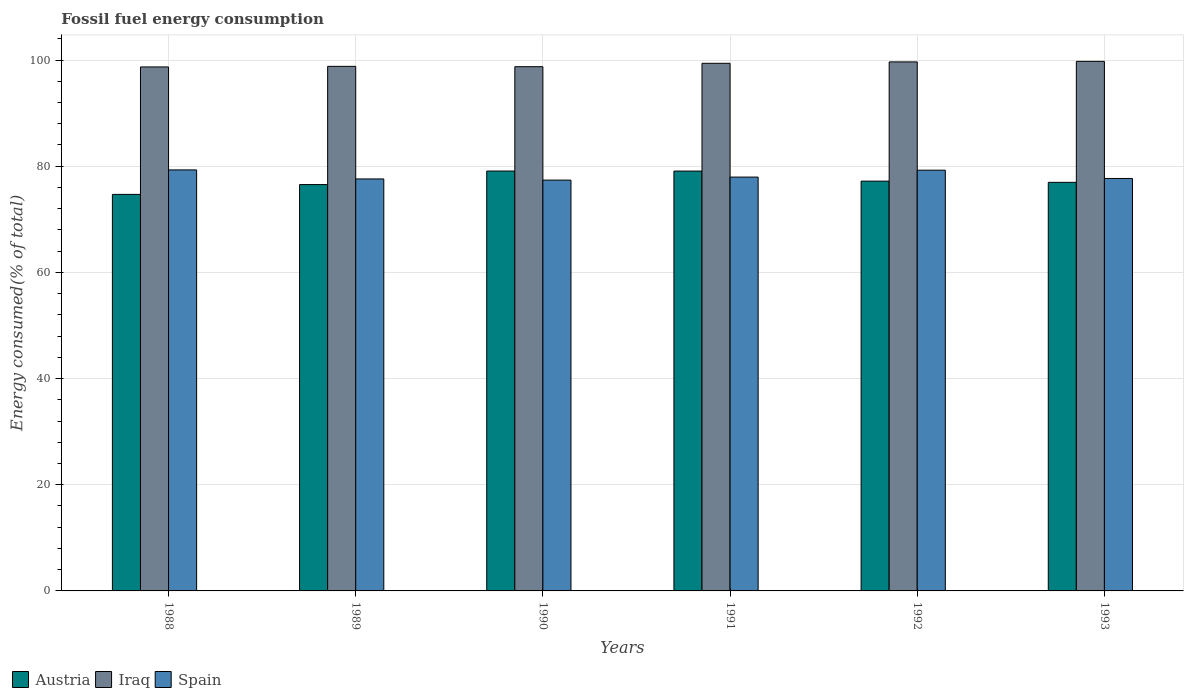How many groups of bars are there?
Offer a very short reply. 6. Are the number of bars per tick equal to the number of legend labels?
Offer a terse response. Yes. In how many cases, is the number of bars for a given year not equal to the number of legend labels?
Offer a very short reply. 0. What is the percentage of energy consumed in Austria in 1991?
Provide a succinct answer. 79.09. Across all years, what is the maximum percentage of energy consumed in Spain?
Offer a terse response. 79.3. Across all years, what is the minimum percentage of energy consumed in Austria?
Your response must be concise. 74.69. In which year was the percentage of energy consumed in Spain minimum?
Your response must be concise. 1990. What is the total percentage of energy consumed in Spain in the graph?
Make the answer very short. 469.19. What is the difference between the percentage of energy consumed in Spain in 1990 and that in 1993?
Your answer should be very brief. -0.31. What is the difference between the percentage of energy consumed in Spain in 1988 and the percentage of energy consumed in Iraq in 1993?
Make the answer very short. -20.45. What is the average percentage of energy consumed in Iraq per year?
Give a very brief answer. 99.18. In the year 1988, what is the difference between the percentage of energy consumed in Iraq and percentage of energy consumed in Spain?
Your answer should be compact. 19.4. In how many years, is the percentage of energy consumed in Spain greater than 56 %?
Offer a very short reply. 6. What is the ratio of the percentage of energy consumed in Spain in 1990 to that in 1991?
Your response must be concise. 0.99. Is the percentage of energy consumed in Spain in 1988 less than that in 1989?
Offer a very short reply. No. Is the difference between the percentage of energy consumed in Iraq in 1991 and 1993 greater than the difference between the percentage of energy consumed in Spain in 1991 and 1993?
Your answer should be compact. No. What is the difference between the highest and the second highest percentage of energy consumed in Austria?
Keep it short and to the point. 0.01. What is the difference between the highest and the lowest percentage of energy consumed in Spain?
Your answer should be very brief. 1.92. In how many years, is the percentage of energy consumed in Spain greater than the average percentage of energy consumed in Spain taken over all years?
Ensure brevity in your answer.  2. Is the sum of the percentage of energy consumed in Spain in 1990 and 1991 greater than the maximum percentage of energy consumed in Iraq across all years?
Provide a short and direct response. Yes. What does the 2nd bar from the left in 1993 represents?
Your answer should be compact. Iraq. What does the 3rd bar from the right in 1990 represents?
Your response must be concise. Austria. Is it the case that in every year, the sum of the percentage of energy consumed in Austria and percentage of energy consumed in Iraq is greater than the percentage of energy consumed in Spain?
Provide a succinct answer. Yes. Are all the bars in the graph horizontal?
Your answer should be very brief. No. How many years are there in the graph?
Make the answer very short. 6. Are the values on the major ticks of Y-axis written in scientific E-notation?
Provide a succinct answer. No. Does the graph contain any zero values?
Keep it short and to the point. No. Does the graph contain grids?
Offer a terse response. Yes. Where does the legend appear in the graph?
Offer a terse response. Bottom left. How many legend labels are there?
Keep it short and to the point. 3. What is the title of the graph?
Keep it short and to the point. Fossil fuel energy consumption. Does "Suriname" appear as one of the legend labels in the graph?
Your answer should be very brief. No. What is the label or title of the X-axis?
Your answer should be very brief. Years. What is the label or title of the Y-axis?
Provide a short and direct response. Energy consumed(% of total). What is the Energy consumed(% of total) of Austria in 1988?
Your answer should be very brief. 74.69. What is the Energy consumed(% of total) of Iraq in 1988?
Provide a short and direct response. 98.7. What is the Energy consumed(% of total) in Spain in 1988?
Make the answer very short. 79.3. What is the Energy consumed(% of total) in Austria in 1989?
Provide a short and direct response. 76.54. What is the Energy consumed(% of total) in Iraq in 1989?
Give a very brief answer. 98.81. What is the Energy consumed(% of total) of Spain in 1989?
Keep it short and to the point. 77.6. What is the Energy consumed(% of total) in Austria in 1990?
Ensure brevity in your answer.  79.09. What is the Energy consumed(% of total) of Iraq in 1990?
Provide a short and direct response. 98.75. What is the Energy consumed(% of total) of Spain in 1990?
Ensure brevity in your answer.  77.39. What is the Energy consumed(% of total) of Austria in 1991?
Your response must be concise. 79.09. What is the Energy consumed(% of total) in Iraq in 1991?
Keep it short and to the point. 99.39. What is the Energy consumed(% of total) of Spain in 1991?
Your response must be concise. 77.95. What is the Energy consumed(% of total) of Austria in 1992?
Your answer should be very brief. 77.19. What is the Energy consumed(% of total) in Iraq in 1992?
Give a very brief answer. 99.65. What is the Energy consumed(% of total) of Spain in 1992?
Give a very brief answer. 79.25. What is the Energy consumed(% of total) in Austria in 1993?
Your response must be concise. 76.96. What is the Energy consumed(% of total) in Iraq in 1993?
Your answer should be compact. 99.75. What is the Energy consumed(% of total) of Spain in 1993?
Provide a short and direct response. 77.69. Across all years, what is the maximum Energy consumed(% of total) in Austria?
Your answer should be very brief. 79.09. Across all years, what is the maximum Energy consumed(% of total) in Iraq?
Provide a succinct answer. 99.75. Across all years, what is the maximum Energy consumed(% of total) of Spain?
Provide a succinct answer. 79.3. Across all years, what is the minimum Energy consumed(% of total) in Austria?
Provide a short and direct response. 74.69. Across all years, what is the minimum Energy consumed(% of total) in Iraq?
Ensure brevity in your answer.  98.7. Across all years, what is the minimum Energy consumed(% of total) in Spain?
Give a very brief answer. 77.39. What is the total Energy consumed(% of total) in Austria in the graph?
Offer a terse response. 463.57. What is the total Energy consumed(% of total) in Iraq in the graph?
Your answer should be compact. 595.06. What is the total Energy consumed(% of total) in Spain in the graph?
Your answer should be very brief. 469.19. What is the difference between the Energy consumed(% of total) of Austria in 1988 and that in 1989?
Offer a terse response. -1.85. What is the difference between the Energy consumed(% of total) of Iraq in 1988 and that in 1989?
Your response must be concise. -0.11. What is the difference between the Energy consumed(% of total) of Spain in 1988 and that in 1989?
Provide a short and direct response. 1.7. What is the difference between the Energy consumed(% of total) of Austria in 1988 and that in 1990?
Ensure brevity in your answer.  -4.4. What is the difference between the Energy consumed(% of total) of Iraq in 1988 and that in 1990?
Ensure brevity in your answer.  -0.05. What is the difference between the Energy consumed(% of total) of Spain in 1988 and that in 1990?
Provide a succinct answer. 1.92. What is the difference between the Energy consumed(% of total) in Austria in 1988 and that in 1991?
Your answer should be compact. -4.39. What is the difference between the Energy consumed(% of total) of Iraq in 1988 and that in 1991?
Provide a succinct answer. -0.68. What is the difference between the Energy consumed(% of total) of Spain in 1988 and that in 1991?
Your response must be concise. 1.35. What is the difference between the Energy consumed(% of total) in Austria in 1988 and that in 1992?
Offer a very short reply. -2.5. What is the difference between the Energy consumed(% of total) in Iraq in 1988 and that in 1992?
Offer a terse response. -0.95. What is the difference between the Energy consumed(% of total) in Spain in 1988 and that in 1992?
Keep it short and to the point. 0.05. What is the difference between the Energy consumed(% of total) of Austria in 1988 and that in 1993?
Ensure brevity in your answer.  -2.27. What is the difference between the Energy consumed(% of total) in Iraq in 1988 and that in 1993?
Your response must be concise. -1.05. What is the difference between the Energy consumed(% of total) of Spain in 1988 and that in 1993?
Make the answer very short. 1.61. What is the difference between the Energy consumed(% of total) in Austria in 1989 and that in 1990?
Your answer should be compact. -2.55. What is the difference between the Energy consumed(% of total) of Iraq in 1989 and that in 1990?
Provide a short and direct response. 0.06. What is the difference between the Energy consumed(% of total) of Spain in 1989 and that in 1990?
Your response must be concise. 0.22. What is the difference between the Energy consumed(% of total) of Austria in 1989 and that in 1991?
Provide a succinct answer. -2.54. What is the difference between the Energy consumed(% of total) in Iraq in 1989 and that in 1991?
Your answer should be very brief. -0.57. What is the difference between the Energy consumed(% of total) in Spain in 1989 and that in 1991?
Offer a very short reply. -0.35. What is the difference between the Energy consumed(% of total) of Austria in 1989 and that in 1992?
Your answer should be compact. -0.65. What is the difference between the Energy consumed(% of total) of Iraq in 1989 and that in 1992?
Give a very brief answer. -0.84. What is the difference between the Energy consumed(% of total) in Spain in 1989 and that in 1992?
Provide a short and direct response. -1.65. What is the difference between the Energy consumed(% of total) of Austria in 1989 and that in 1993?
Your response must be concise. -0.42. What is the difference between the Energy consumed(% of total) in Iraq in 1989 and that in 1993?
Keep it short and to the point. -0.94. What is the difference between the Energy consumed(% of total) in Spain in 1989 and that in 1993?
Make the answer very short. -0.09. What is the difference between the Energy consumed(% of total) of Austria in 1990 and that in 1991?
Make the answer very short. 0.01. What is the difference between the Energy consumed(% of total) in Iraq in 1990 and that in 1991?
Give a very brief answer. -0.64. What is the difference between the Energy consumed(% of total) in Spain in 1990 and that in 1991?
Keep it short and to the point. -0.57. What is the difference between the Energy consumed(% of total) of Austria in 1990 and that in 1992?
Provide a short and direct response. 1.9. What is the difference between the Energy consumed(% of total) in Iraq in 1990 and that in 1992?
Your answer should be compact. -0.9. What is the difference between the Energy consumed(% of total) of Spain in 1990 and that in 1992?
Keep it short and to the point. -1.87. What is the difference between the Energy consumed(% of total) in Austria in 1990 and that in 1993?
Give a very brief answer. 2.13. What is the difference between the Energy consumed(% of total) in Iraq in 1990 and that in 1993?
Provide a succinct answer. -1. What is the difference between the Energy consumed(% of total) in Spain in 1990 and that in 1993?
Provide a short and direct response. -0.31. What is the difference between the Energy consumed(% of total) of Austria in 1991 and that in 1992?
Your response must be concise. 1.89. What is the difference between the Energy consumed(% of total) in Iraq in 1991 and that in 1992?
Your answer should be compact. -0.26. What is the difference between the Energy consumed(% of total) of Spain in 1991 and that in 1992?
Your answer should be compact. -1.3. What is the difference between the Energy consumed(% of total) of Austria in 1991 and that in 1993?
Keep it short and to the point. 2.12. What is the difference between the Energy consumed(% of total) in Iraq in 1991 and that in 1993?
Ensure brevity in your answer.  -0.37. What is the difference between the Energy consumed(% of total) in Spain in 1991 and that in 1993?
Make the answer very short. 0.26. What is the difference between the Energy consumed(% of total) in Austria in 1992 and that in 1993?
Make the answer very short. 0.23. What is the difference between the Energy consumed(% of total) in Iraq in 1992 and that in 1993?
Make the answer very short. -0.1. What is the difference between the Energy consumed(% of total) in Spain in 1992 and that in 1993?
Keep it short and to the point. 1.56. What is the difference between the Energy consumed(% of total) of Austria in 1988 and the Energy consumed(% of total) of Iraq in 1989?
Your response must be concise. -24.12. What is the difference between the Energy consumed(% of total) of Austria in 1988 and the Energy consumed(% of total) of Spain in 1989?
Provide a succinct answer. -2.91. What is the difference between the Energy consumed(% of total) in Iraq in 1988 and the Energy consumed(% of total) in Spain in 1989?
Your answer should be compact. 21.1. What is the difference between the Energy consumed(% of total) in Austria in 1988 and the Energy consumed(% of total) in Iraq in 1990?
Your answer should be very brief. -24.06. What is the difference between the Energy consumed(% of total) of Austria in 1988 and the Energy consumed(% of total) of Spain in 1990?
Offer a very short reply. -2.69. What is the difference between the Energy consumed(% of total) in Iraq in 1988 and the Energy consumed(% of total) in Spain in 1990?
Give a very brief answer. 21.32. What is the difference between the Energy consumed(% of total) in Austria in 1988 and the Energy consumed(% of total) in Iraq in 1991?
Offer a terse response. -24.69. What is the difference between the Energy consumed(% of total) of Austria in 1988 and the Energy consumed(% of total) of Spain in 1991?
Keep it short and to the point. -3.26. What is the difference between the Energy consumed(% of total) of Iraq in 1988 and the Energy consumed(% of total) of Spain in 1991?
Your answer should be compact. 20.75. What is the difference between the Energy consumed(% of total) of Austria in 1988 and the Energy consumed(% of total) of Iraq in 1992?
Your response must be concise. -24.96. What is the difference between the Energy consumed(% of total) in Austria in 1988 and the Energy consumed(% of total) in Spain in 1992?
Make the answer very short. -4.56. What is the difference between the Energy consumed(% of total) of Iraq in 1988 and the Energy consumed(% of total) of Spain in 1992?
Provide a succinct answer. 19.45. What is the difference between the Energy consumed(% of total) in Austria in 1988 and the Energy consumed(% of total) in Iraq in 1993?
Keep it short and to the point. -25.06. What is the difference between the Energy consumed(% of total) in Austria in 1988 and the Energy consumed(% of total) in Spain in 1993?
Provide a succinct answer. -3. What is the difference between the Energy consumed(% of total) of Iraq in 1988 and the Energy consumed(% of total) of Spain in 1993?
Make the answer very short. 21.01. What is the difference between the Energy consumed(% of total) of Austria in 1989 and the Energy consumed(% of total) of Iraq in 1990?
Offer a very short reply. -22.2. What is the difference between the Energy consumed(% of total) in Austria in 1989 and the Energy consumed(% of total) in Spain in 1990?
Provide a short and direct response. -0.84. What is the difference between the Energy consumed(% of total) of Iraq in 1989 and the Energy consumed(% of total) of Spain in 1990?
Make the answer very short. 21.43. What is the difference between the Energy consumed(% of total) in Austria in 1989 and the Energy consumed(% of total) in Iraq in 1991?
Keep it short and to the point. -22.84. What is the difference between the Energy consumed(% of total) of Austria in 1989 and the Energy consumed(% of total) of Spain in 1991?
Give a very brief answer. -1.41. What is the difference between the Energy consumed(% of total) in Iraq in 1989 and the Energy consumed(% of total) in Spain in 1991?
Your answer should be very brief. 20.86. What is the difference between the Energy consumed(% of total) in Austria in 1989 and the Energy consumed(% of total) in Iraq in 1992?
Keep it short and to the point. -23.11. What is the difference between the Energy consumed(% of total) in Austria in 1989 and the Energy consumed(% of total) in Spain in 1992?
Ensure brevity in your answer.  -2.71. What is the difference between the Energy consumed(% of total) of Iraq in 1989 and the Energy consumed(% of total) of Spain in 1992?
Your response must be concise. 19.56. What is the difference between the Energy consumed(% of total) in Austria in 1989 and the Energy consumed(% of total) in Iraq in 1993?
Keep it short and to the point. -23.21. What is the difference between the Energy consumed(% of total) of Austria in 1989 and the Energy consumed(% of total) of Spain in 1993?
Keep it short and to the point. -1.15. What is the difference between the Energy consumed(% of total) in Iraq in 1989 and the Energy consumed(% of total) in Spain in 1993?
Offer a terse response. 21.12. What is the difference between the Energy consumed(% of total) of Austria in 1990 and the Energy consumed(% of total) of Iraq in 1991?
Keep it short and to the point. -20.3. What is the difference between the Energy consumed(% of total) in Austria in 1990 and the Energy consumed(% of total) in Spain in 1991?
Offer a very short reply. 1.14. What is the difference between the Energy consumed(% of total) in Iraq in 1990 and the Energy consumed(% of total) in Spain in 1991?
Offer a terse response. 20.8. What is the difference between the Energy consumed(% of total) of Austria in 1990 and the Energy consumed(% of total) of Iraq in 1992?
Make the answer very short. -20.56. What is the difference between the Energy consumed(% of total) in Austria in 1990 and the Energy consumed(% of total) in Spain in 1992?
Your answer should be very brief. -0.16. What is the difference between the Energy consumed(% of total) in Iraq in 1990 and the Energy consumed(% of total) in Spain in 1992?
Give a very brief answer. 19.49. What is the difference between the Energy consumed(% of total) of Austria in 1990 and the Energy consumed(% of total) of Iraq in 1993?
Offer a very short reply. -20.66. What is the difference between the Energy consumed(% of total) in Austria in 1990 and the Energy consumed(% of total) in Spain in 1993?
Offer a terse response. 1.4. What is the difference between the Energy consumed(% of total) in Iraq in 1990 and the Energy consumed(% of total) in Spain in 1993?
Provide a succinct answer. 21.06. What is the difference between the Energy consumed(% of total) of Austria in 1991 and the Energy consumed(% of total) of Iraq in 1992?
Your response must be concise. -20.56. What is the difference between the Energy consumed(% of total) of Austria in 1991 and the Energy consumed(% of total) of Spain in 1992?
Your answer should be compact. -0.17. What is the difference between the Energy consumed(% of total) of Iraq in 1991 and the Energy consumed(% of total) of Spain in 1992?
Provide a short and direct response. 20.13. What is the difference between the Energy consumed(% of total) of Austria in 1991 and the Energy consumed(% of total) of Iraq in 1993?
Offer a very short reply. -20.67. What is the difference between the Energy consumed(% of total) in Austria in 1991 and the Energy consumed(% of total) in Spain in 1993?
Ensure brevity in your answer.  1.39. What is the difference between the Energy consumed(% of total) of Iraq in 1991 and the Energy consumed(% of total) of Spain in 1993?
Offer a very short reply. 21.7. What is the difference between the Energy consumed(% of total) in Austria in 1992 and the Energy consumed(% of total) in Iraq in 1993?
Provide a succinct answer. -22.56. What is the difference between the Energy consumed(% of total) in Austria in 1992 and the Energy consumed(% of total) in Spain in 1993?
Provide a succinct answer. -0.5. What is the difference between the Energy consumed(% of total) of Iraq in 1992 and the Energy consumed(% of total) of Spain in 1993?
Keep it short and to the point. 21.96. What is the average Energy consumed(% of total) of Austria per year?
Make the answer very short. 77.26. What is the average Energy consumed(% of total) in Iraq per year?
Offer a very short reply. 99.18. What is the average Energy consumed(% of total) of Spain per year?
Your answer should be very brief. 78.2. In the year 1988, what is the difference between the Energy consumed(% of total) in Austria and Energy consumed(% of total) in Iraq?
Your response must be concise. -24.01. In the year 1988, what is the difference between the Energy consumed(% of total) in Austria and Energy consumed(% of total) in Spain?
Offer a terse response. -4.61. In the year 1988, what is the difference between the Energy consumed(% of total) in Iraq and Energy consumed(% of total) in Spain?
Offer a terse response. 19.4. In the year 1989, what is the difference between the Energy consumed(% of total) in Austria and Energy consumed(% of total) in Iraq?
Your answer should be compact. -22.27. In the year 1989, what is the difference between the Energy consumed(% of total) in Austria and Energy consumed(% of total) in Spain?
Provide a short and direct response. -1.06. In the year 1989, what is the difference between the Energy consumed(% of total) of Iraq and Energy consumed(% of total) of Spain?
Offer a terse response. 21.21. In the year 1990, what is the difference between the Energy consumed(% of total) in Austria and Energy consumed(% of total) in Iraq?
Provide a succinct answer. -19.66. In the year 1990, what is the difference between the Energy consumed(% of total) in Austria and Energy consumed(% of total) in Spain?
Offer a very short reply. 1.71. In the year 1990, what is the difference between the Energy consumed(% of total) in Iraq and Energy consumed(% of total) in Spain?
Your answer should be compact. 21.36. In the year 1991, what is the difference between the Energy consumed(% of total) of Austria and Energy consumed(% of total) of Iraq?
Give a very brief answer. -20.3. In the year 1991, what is the difference between the Energy consumed(% of total) in Austria and Energy consumed(% of total) in Spain?
Give a very brief answer. 1.13. In the year 1991, what is the difference between the Energy consumed(% of total) in Iraq and Energy consumed(% of total) in Spain?
Your answer should be very brief. 21.44. In the year 1992, what is the difference between the Energy consumed(% of total) in Austria and Energy consumed(% of total) in Iraq?
Make the answer very short. -22.46. In the year 1992, what is the difference between the Energy consumed(% of total) in Austria and Energy consumed(% of total) in Spain?
Ensure brevity in your answer.  -2.06. In the year 1992, what is the difference between the Energy consumed(% of total) of Iraq and Energy consumed(% of total) of Spain?
Your answer should be very brief. 20.4. In the year 1993, what is the difference between the Energy consumed(% of total) in Austria and Energy consumed(% of total) in Iraq?
Your answer should be compact. -22.79. In the year 1993, what is the difference between the Energy consumed(% of total) in Austria and Energy consumed(% of total) in Spain?
Offer a terse response. -0.73. In the year 1993, what is the difference between the Energy consumed(% of total) of Iraq and Energy consumed(% of total) of Spain?
Your response must be concise. 22.06. What is the ratio of the Energy consumed(% of total) in Austria in 1988 to that in 1989?
Give a very brief answer. 0.98. What is the ratio of the Energy consumed(% of total) of Spain in 1988 to that in 1989?
Your answer should be compact. 1.02. What is the ratio of the Energy consumed(% of total) of Iraq in 1988 to that in 1990?
Provide a short and direct response. 1. What is the ratio of the Energy consumed(% of total) in Spain in 1988 to that in 1990?
Provide a short and direct response. 1.02. What is the ratio of the Energy consumed(% of total) in Austria in 1988 to that in 1991?
Your answer should be very brief. 0.94. What is the ratio of the Energy consumed(% of total) in Spain in 1988 to that in 1991?
Offer a terse response. 1.02. What is the ratio of the Energy consumed(% of total) of Austria in 1988 to that in 1992?
Provide a short and direct response. 0.97. What is the ratio of the Energy consumed(% of total) of Iraq in 1988 to that in 1992?
Your answer should be compact. 0.99. What is the ratio of the Energy consumed(% of total) in Austria in 1988 to that in 1993?
Ensure brevity in your answer.  0.97. What is the ratio of the Energy consumed(% of total) of Spain in 1988 to that in 1993?
Give a very brief answer. 1.02. What is the ratio of the Energy consumed(% of total) in Austria in 1989 to that in 1990?
Your answer should be compact. 0.97. What is the ratio of the Energy consumed(% of total) in Austria in 1989 to that in 1991?
Keep it short and to the point. 0.97. What is the ratio of the Energy consumed(% of total) in Iraq in 1989 to that in 1991?
Your answer should be very brief. 0.99. What is the ratio of the Energy consumed(% of total) in Austria in 1989 to that in 1992?
Offer a very short reply. 0.99. What is the ratio of the Energy consumed(% of total) of Iraq in 1989 to that in 1992?
Your answer should be very brief. 0.99. What is the ratio of the Energy consumed(% of total) in Spain in 1989 to that in 1992?
Your answer should be compact. 0.98. What is the ratio of the Energy consumed(% of total) of Austria in 1989 to that in 1993?
Your answer should be very brief. 0.99. What is the ratio of the Energy consumed(% of total) in Iraq in 1989 to that in 1993?
Keep it short and to the point. 0.99. What is the ratio of the Energy consumed(% of total) in Austria in 1990 to that in 1991?
Offer a terse response. 1. What is the ratio of the Energy consumed(% of total) in Iraq in 1990 to that in 1991?
Keep it short and to the point. 0.99. What is the ratio of the Energy consumed(% of total) of Austria in 1990 to that in 1992?
Make the answer very short. 1.02. What is the ratio of the Energy consumed(% of total) of Iraq in 1990 to that in 1992?
Provide a short and direct response. 0.99. What is the ratio of the Energy consumed(% of total) in Spain in 1990 to that in 1992?
Your answer should be compact. 0.98. What is the ratio of the Energy consumed(% of total) in Austria in 1990 to that in 1993?
Ensure brevity in your answer.  1.03. What is the ratio of the Energy consumed(% of total) in Iraq in 1990 to that in 1993?
Your response must be concise. 0.99. What is the ratio of the Energy consumed(% of total) in Austria in 1991 to that in 1992?
Ensure brevity in your answer.  1.02. What is the ratio of the Energy consumed(% of total) in Iraq in 1991 to that in 1992?
Offer a very short reply. 1. What is the ratio of the Energy consumed(% of total) in Spain in 1991 to that in 1992?
Your answer should be very brief. 0.98. What is the ratio of the Energy consumed(% of total) of Austria in 1991 to that in 1993?
Provide a short and direct response. 1.03. What is the ratio of the Energy consumed(% of total) of Iraq in 1991 to that in 1993?
Give a very brief answer. 1. What is the ratio of the Energy consumed(% of total) in Spain in 1991 to that in 1993?
Give a very brief answer. 1. What is the ratio of the Energy consumed(% of total) in Iraq in 1992 to that in 1993?
Provide a short and direct response. 1. What is the ratio of the Energy consumed(% of total) of Spain in 1992 to that in 1993?
Provide a short and direct response. 1.02. What is the difference between the highest and the second highest Energy consumed(% of total) of Austria?
Your answer should be very brief. 0.01. What is the difference between the highest and the second highest Energy consumed(% of total) in Iraq?
Provide a short and direct response. 0.1. What is the difference between the highest and the second highest Energy consumed(% of total) of Spain?
Your response must be concise. 0.05. What is the difference between the highest and the lowest Energy consumed(% of total) of Austria?
Your answer should be compact. 4.4. What is the difference between the highest and the lowest Energy consumed(% of total) in Iraq?
Ensure brevity in your answer.  1.05. What is the difference between the highest and the lowest Energy consumed(% of total) of Spain?
Your answer should be compact. 1.92. 